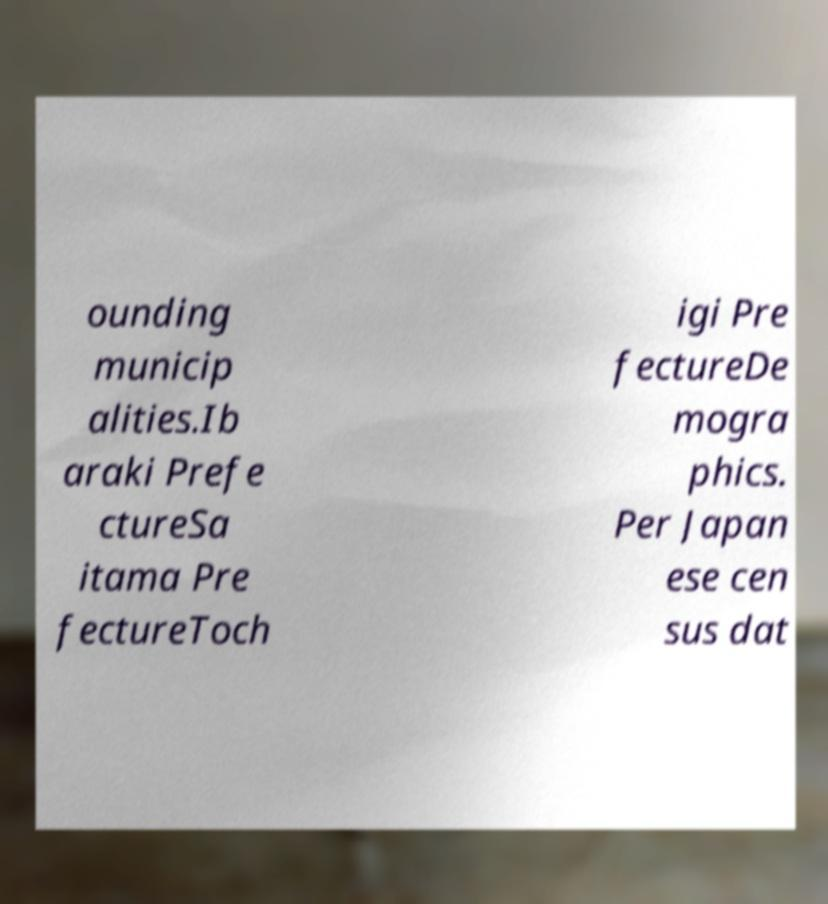Could you assist in decoding the text presented in this image and type it out clearly? ounding municip alities.Ib araki Prefe ctureSa itama Pre fectureToch igi Pre fectureDe mogra phics. Per Japan ese cen sus dat 